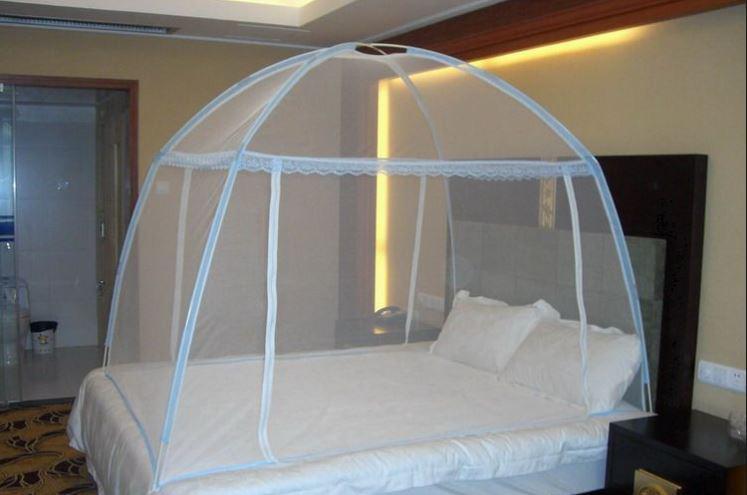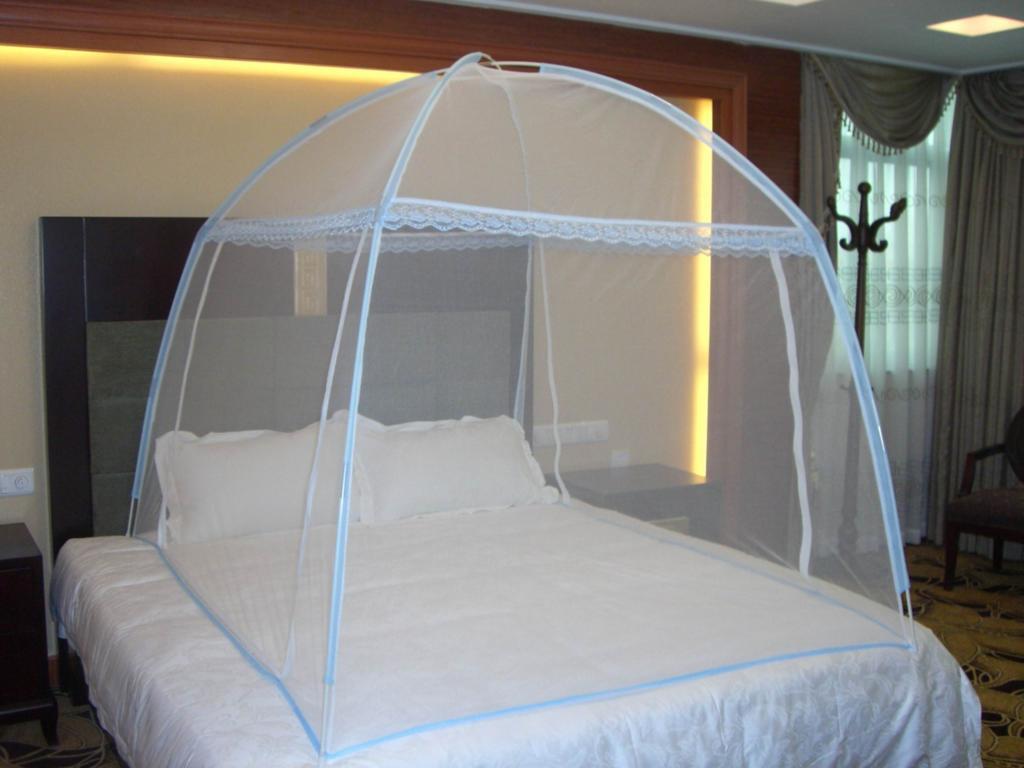The first image is the image on the left, the second image is the image on the right. For the images displayed, is the sentence "Each image shows a canopy with a dome top and trim in a shade of blue over a bed with no one on it." factually correct? Answer yes or no. Yes. The first image is the image on the left, the second image is the image on the right. Assess this claim about the two images: "One bed net has a fabric bottom trim.". Correct or not? Answer yes or no. No. 